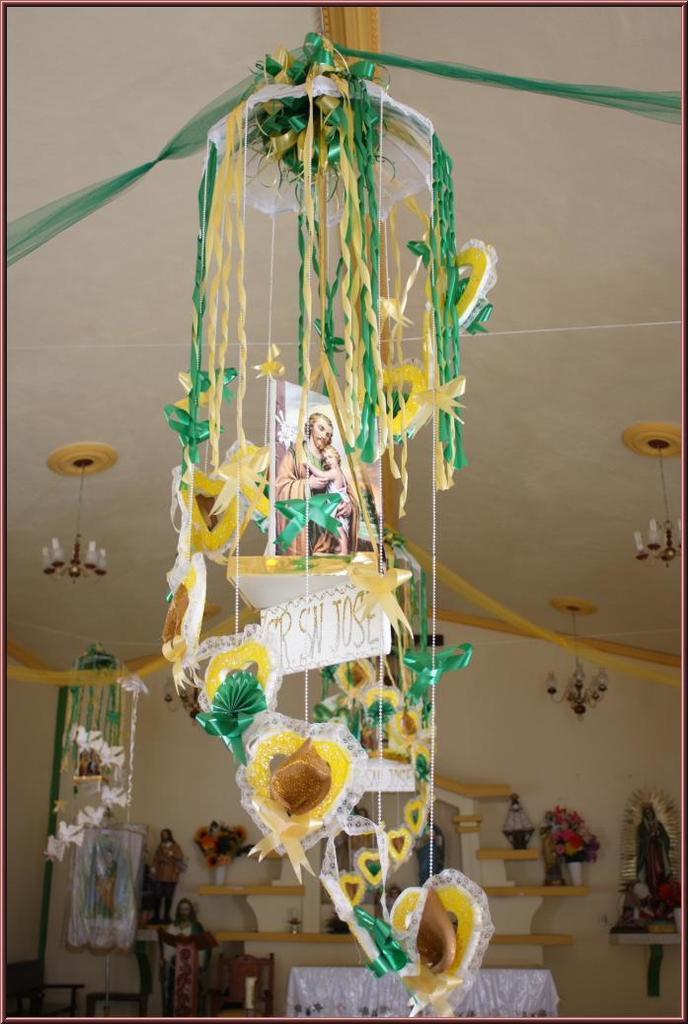Could you give a brief overview of what you see in this image? The image is taken in the room. In the center of the image there is a table and we can see a shelf. There are things placed in the shelf. At the top there are wind chimes attached to the roof and we can see decors. 